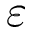Convert formula to latex. <formula><loc_0><loc_0><loc_500><loc_500>\varepsilon</formula> 